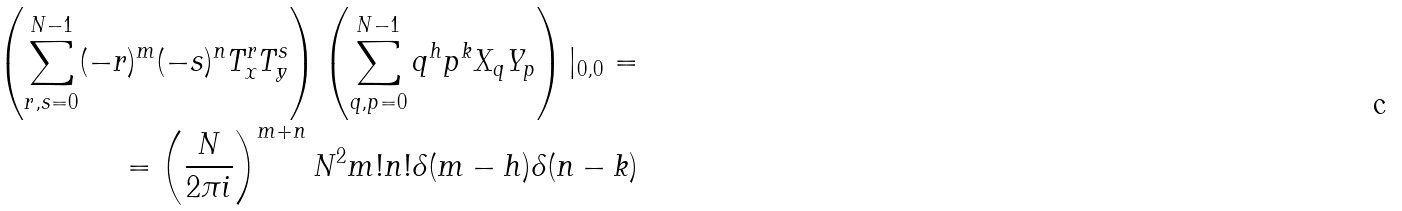<formula> <loc_0><loc_0><loc_500><loc_500>\left ( \sum _ { r , s = 0 } ^ { N - 1 } ( - r ) ^ { m } ( - s ) ^ { n } T _ { x } ^ { r } T _ { y } ^ { s } \right ) \left ( \sum _ { q , p = 0 } ^ { N - 1 } q ^ { h } p ^ { k } X _ { q } Y _ { p } \right ) | _ { 0 , 0 } = \\ \text { \quad } = \left ( \frac { N } { 2 \pi i } \right ) ^ { m + n } N ^ { 2 } m ! n ! \delta ( m - h ) \delta ( n - k )</formula> 